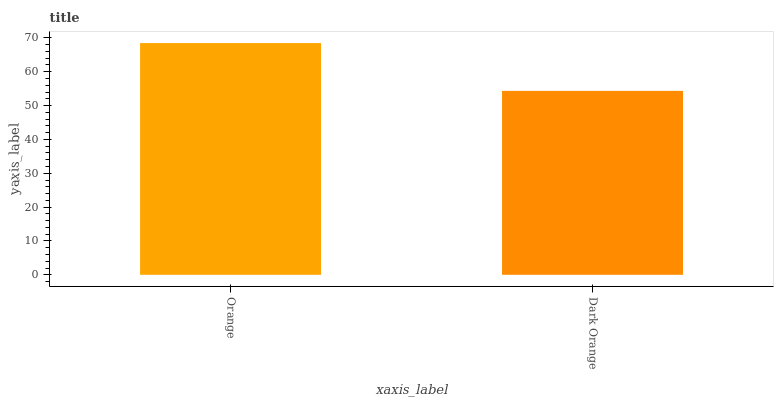Is Dark Orange the minimum?
Answer yes or no. Yes. Is Orange the maximum?
Answer yes or no. Yes. Is Dark Orange the maximum?
Answer yes or no. No. Is Orange greater than Dark Orange?
Answer yes or no. Yes. Is Dark Orange less than Orange?
Answer yes or no. Yes. Is Dark Orange greater than Orange?
Answer yes or no. No. Is Orange less than Dark Orange?
Answer yes or no. No. Is Orange the high median?
Answer yes or no. Yes. Is Dark Orange the low median?
Answer yes or no. Yes. Is Dark Orange the high median?
Answer yes or no. No. Is Orange the low median?
Answer yes or no. No. 